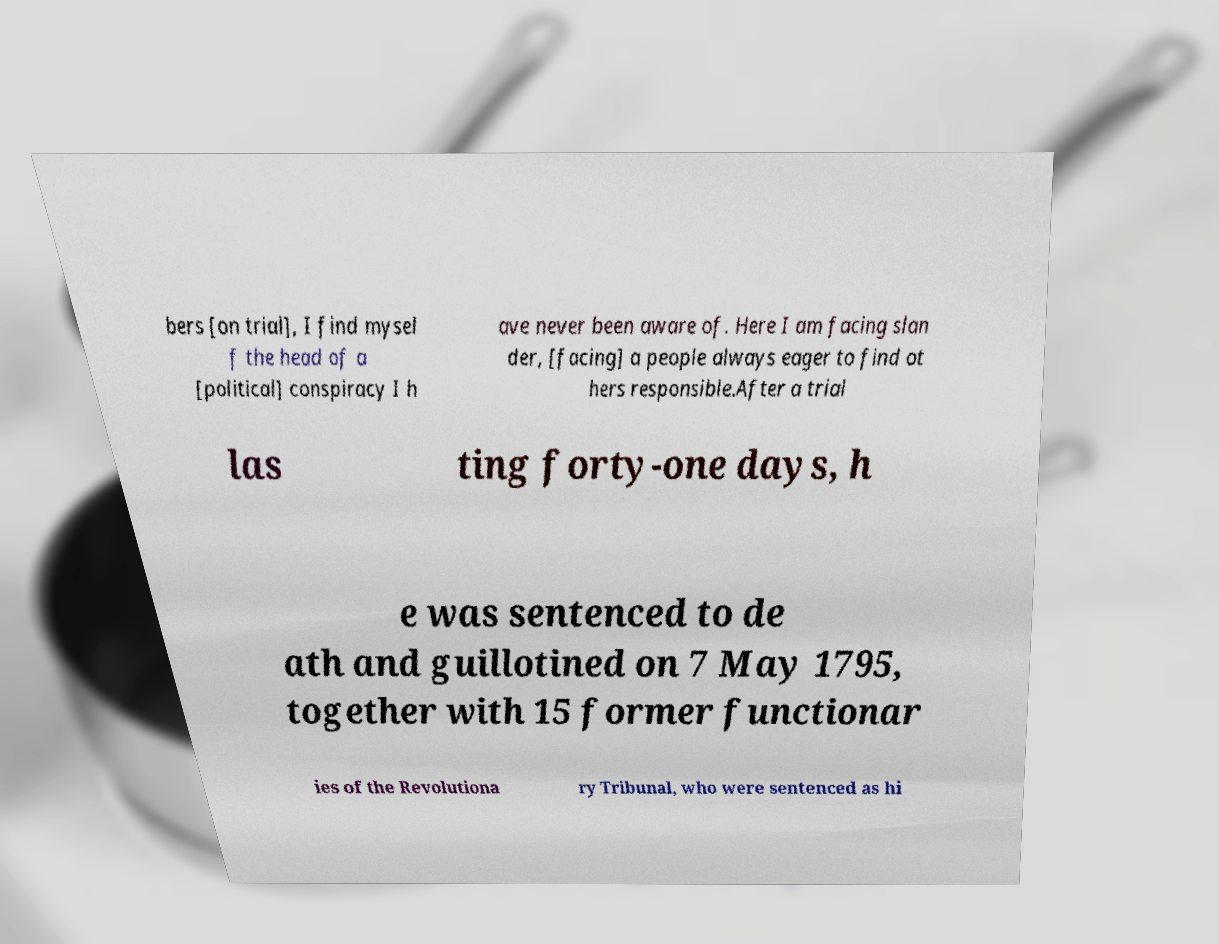What messages or text are displayed in this image? I need them in a readable, typed format. bers [on trial], I find mysel f the head of a [political] conspiracy I h ave never been aware of. Here I am facing slan der, [facing] a people always eager to find ot hers responsible.After a trial las ting forty-one days, h e was sentenced to de ath and guillotined on 7 May 1795, together with 15 former functionar ies of the Revolutiona ry Tribunal, who were sentenced as hi 